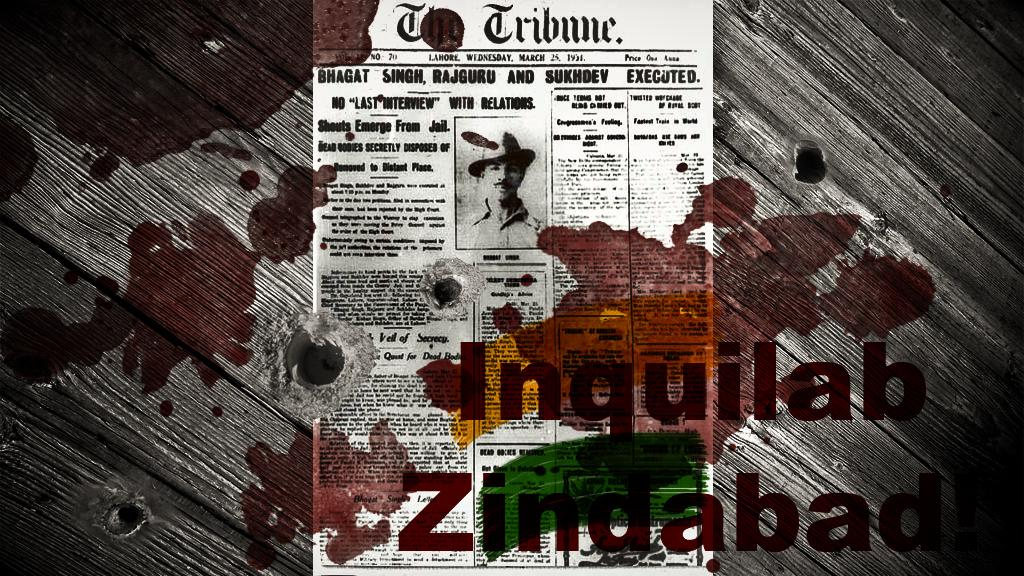<image>
Provide a brief description of the given image. a newspaper with the word Tribune at the top 